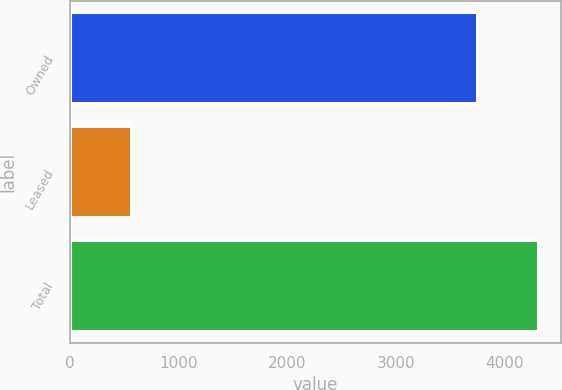Convert chart. <chart><loc_0><loc_0><loc_500><loc_500><bar_chart><fcel>Owned<fcel>Leased<fcel>Total<nl><fcel>3745<fcel>564<fcel>4309<nl></chart> 